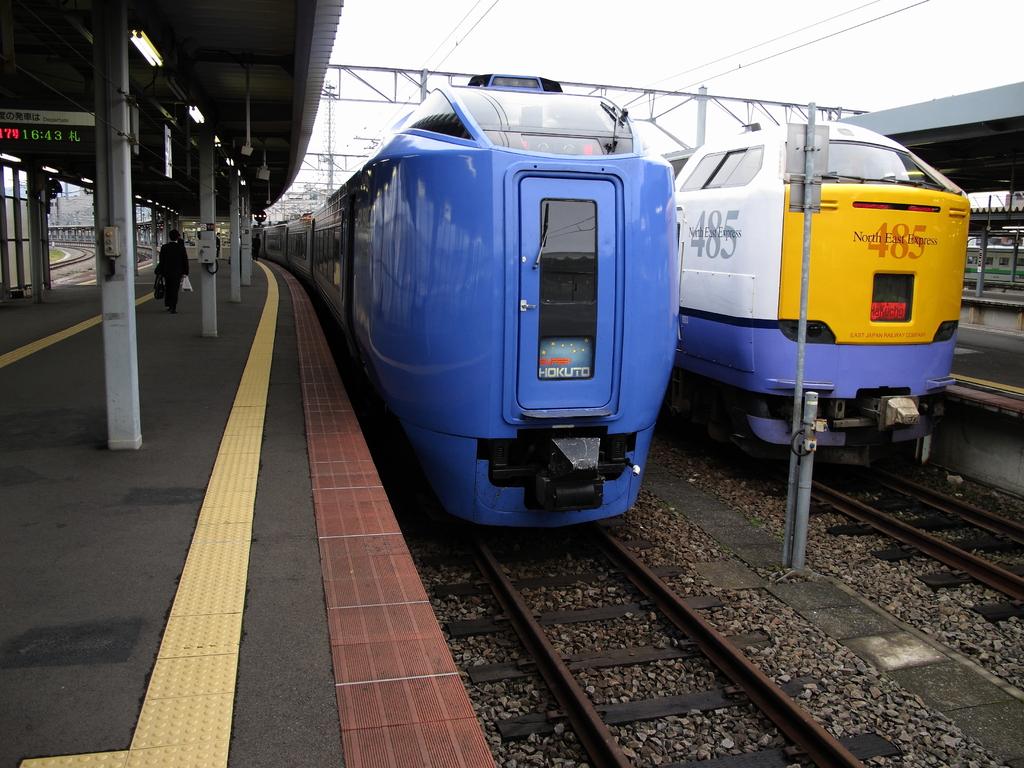What number is the train on the right?
Keep it short and to the point. 485. What's on the fromt left of the right hand train?
Provide a short and direct response. 485. 